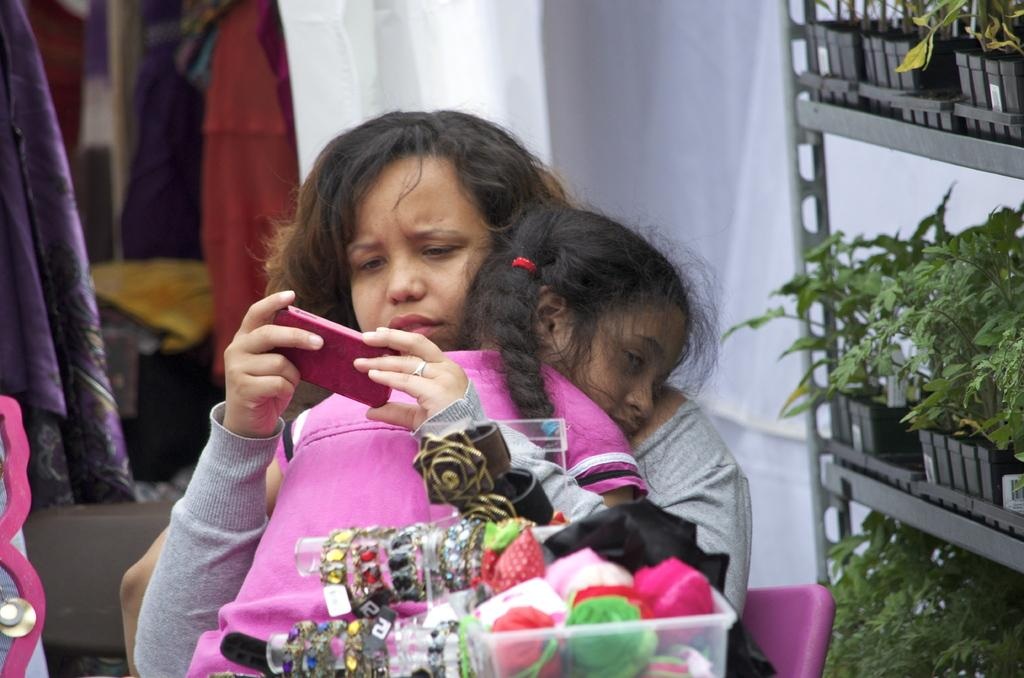What is the lady holding in the image? The lady is holding a girl and a mobile in the image. What can be seen in front of the lady and the girl? There are ornaments in front of the lady and the girl. What is located on the right side of the image? There are pots with plants on racks on the right side of the image. What can be seen in the background of the image? There are clothes visible in the background of the image. Where is the clock located in the image? There is no clock present in the image. What type of pipe is visible in the image? There is no pipe present in the image. 